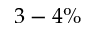Convert formula to latex. <formula><loc_0><loc_0><loc_500><loc_500>3 - 4 \%</formula> 